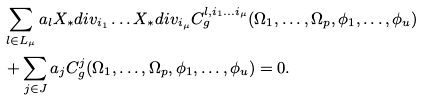Convert formula to latex. <formula><loc_0><loc_0><loc_500><loc_500>& \sum _ { l \in L _ { \mu } } a _ { l } X _ { * } d i v _ { i _ { 1 } } \dots X _ { * } d i v _ { i _ { \mu } } C ^ { l , i _ { 1 } \dots i _ { \mu } } _ { g } ( \Omega _ { 1 } , \dots , \Omega _ { p } , \phi _ { 1 } , \dots , \phi _ { u } ) \\ & + \sum _ { j \in J } a _ { j } C ^ { j } _ { g } ( \Omega _ { 1 } , \dots , \Omega _ { p } , \phi _ { 1 } , \dots , \phi _ { u } ) = 0 .</formula> 